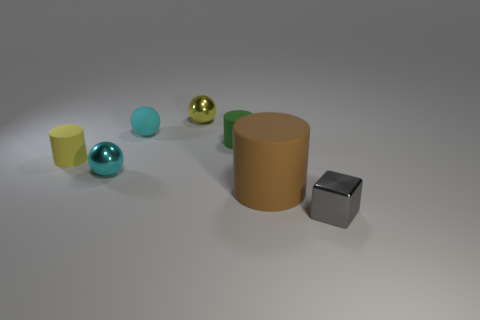Do the tiny cyan matte object and the object right of the brown cylinder have the same shape?
Your answer should be compact. No. The small metallic object that is the same color as the tiny rubber sphere is what shape?
Offer a very short reply. Sphere. There is a cyan sphere behind the cyan thing in front of the green object; what number of big cylinders are to the left of it?
Your answer should be very brief. 0. There is a cylinder that is the same size as the green rubber thing; what is its color?
Provide a short and direct response. Yellow. How big is the matte thing on the right side of the tiny cylinder that is right of the yellow shiny thing?
Provide a succinct answer. Large. There is a metallic sphere that is the same color as the matte ball; what is its size?
Your response must be concise. Small. How many other things are the same size as the gray cube?
Ensure brevity in your answer.  5. What number of cylinders are there?
Offer a terse response. 3. Do the cyan metal sphere and the gray object have the same size?
Keep it short and to the point. Yes. How many other objects are there of the same shape as the tiny yellow metal thing?
Provide a succinct answer. 2. 